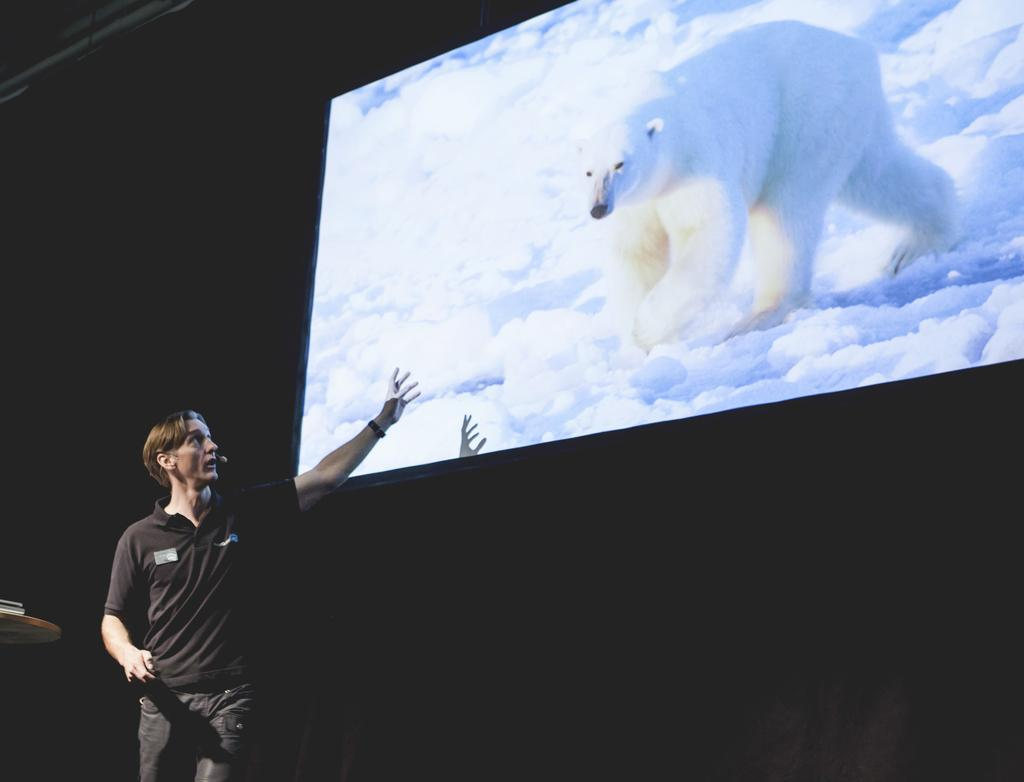What is the man in the image doing? The man is standing and talking. What can be found on the table in the image? There is an object on the table. What is visible on the screen in the image? The screen displays a polar bear and snow. How would you describe the lighting in the image? The background of the image is dark. How does the man wash his hands in the image? There is no indication in the image that the man is washing his hands, so it cannot be determined from the picture. 